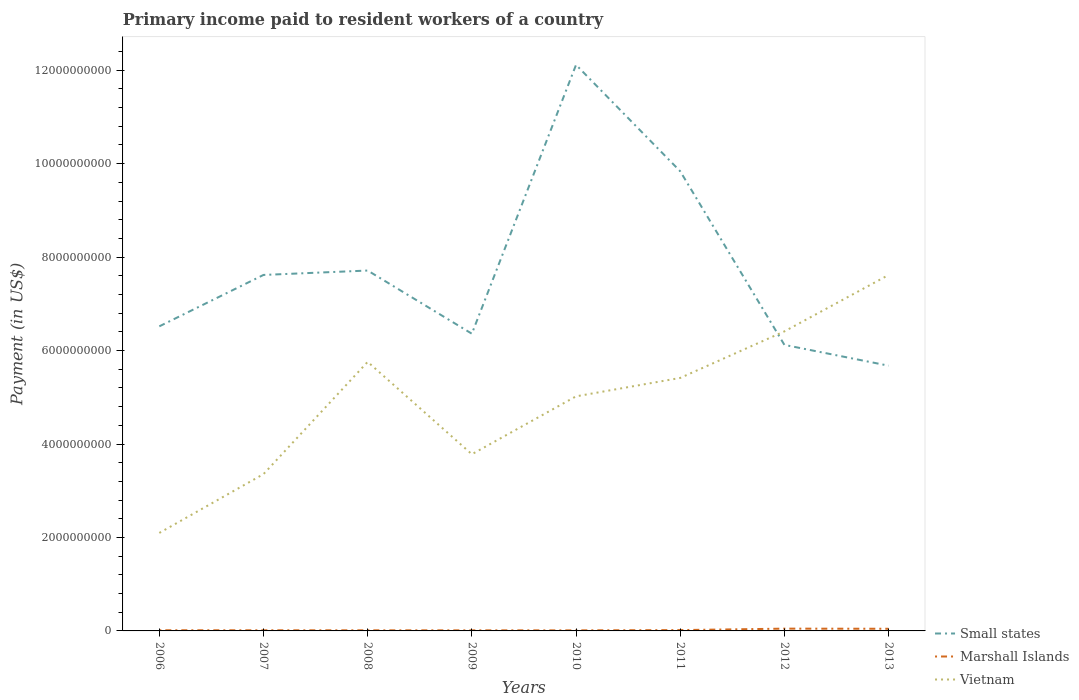How many different coloured lines are there?
Offer a very short reply. 3. Does the line corresponding to Marshall Islands intersect with the line corresponding to Small states?
Keep it short and to the point. No. Across all years, what is the maximum amount paid to workers in Small states?
Your answer should be very brief. 5.68e+09. In which year was the amount paid to workers in Marshall Islands maximum?
Your answer should be compact. 2010. What is the total amount paid to workers in Marshall Islands in the graph?
Keep it short and to the point. -3.13e+07. What is the difference between the highest and the second highest amount paid to workers in Marshall Islands?
Make the answer very short. 3.69e+07. How many lines are there?
Your answer should be very brief. 3. How many years are there in the graph?
Your response must be concise. 8. Are the values on the major ticks of Y-axis written in scientific E-notation?
Your response must be concise. No. How many legend labels are there?
Your response must be concise. 3. What is the title of the graph?
Your answer should be compact. Primary income paid to resident workers of a country. Does "Malaysia" appear as one of the legend labels in the graph?
Your answer should be compact. No. What is the label or title of the X-axis?
Your answer should be compact. Years. What is the label or title of the Y-axis?
Offer a terse response. Payment (in US$). What is the Payment (in US$) of Small states in 2006?
Offer a very short reply. 6.52e+09. What is the Payment (in US$) of Marshall Islands in 2006?
Keep it short and to the point. 1.44e+07. What is the Payment (in US$) of Vietnam in 2006?
Provide a short and direct response. 2.10e+09. What is the Payment (in US$) of Small states in 2007?
Your answer should be very brief. 7.62e+09. What is the Payment (in US$) in Marshall Islands in 2007?
Give a very brief answer. 1.37e+07. What is the Payment (in US$) of Vietnam in 2007?
Keep it short and to the point. 3.36e+09. What is the Payment (in US$) of Small states in 2008?
Provide a short and direct response. 7.71e+09. What is the Payment (in US$) in Marshall Islands in 2008?
Your response must be concise. 1.29e+07. What is the Payment (in US$) of Vietnam in 2008?
Offer a terse response. 5.76e+09. What is the Payment (in US$) in Small states in 2009?
Offer a terse response. 6.36e+09. What is the Payment (in US$) of Marshall Islands in 2009?
Your answer should be compact. 1.23e+07. What is the Payment (in US$) of Vietnam in 2009?
Keep it short and to the point. 3.78e+09. What is the Payment (in US$) in Small states in 2010?
Your answer should be very brief. 1.21e+1. What is the Payment (in US$) of Marshall Islands in 2010?
Ensure brevity in your answer.  1.21e+07. What is the Payment (in US$) in Vietnam in 2010?
Ensure brevity in your answer.  5.02e+09. What is the Payment (in US$) of Small states in 2011?
Offer a very short reply. 9.84e+09. What is the Payment (in US$) in Marshall Islands in 2011?
Offer a very short reply. 1.76e+07. What is the Payment (in US$) of Vietnam in 2011?
Offer a very short reply. 5.41e+09. What is the Payment (in US$) in Small states in 2012?
Your answer should be very brief. 6.12e+09. What is the Payment (in US$) of Marshall Islands in 2012?
Provide a succinct answer. 4.90e+07. What is the Payment (in US$) in Vietnam in 2012?
Ensure brevity in your answer.  6.41e+09. What is the Payment (in US$) in Small states in 2013?
Offer a terse response. 5.68e+09. What is the Payment (in US$) of Marshall Islands in 2013?
Provide a short and direct response. 4.61e+07. What is the Payment (in US$) in Vietnam in 2013?
Ensure brevity in your answer.  7.62e+09. Across all years, what is the maximum Payment (in US$) of Small states?
Give a very brief answer. 1.21e+1. Across all years, what is the maximum Payment (in US$) of Marshall Islands?
Ensure brevity in your answer.  4.90e+07. Across all years, what is the maximum Payment (in US$) of Vietnam?
Offer a very short reply. 7.62e+09. Across all years, what is the minimum Payment (in US$) in Small states?
Ensure brevity in your answer.  5.68e+09. Across all years, what is the minimum Payment (in US$) in Marshall Islands?
Ensure brevity in your answer.  1.21e+07. Across all years, what is the minimum Payment (in US$) of Vietnam?
Provide a short and direct response. 2.10e+09. What is the total Payment (in US$) in Small states in the graph?
Offer a very short reply. 6.20e+1. What is the total Payment (in US$) in Marshall Islands in the graph?
Keep it short and to the point. 1.78e+08. What is the total Payment (in US$) of Vietnam in the graph?
Your answer should be very brief. 3.95e+1. What is the difference between the Payment (in US$) in Small states in 2006 and that in 2007?
Ensure brevity in your answer.  -1.10e+09. What is the difference between the Payment (in US$) of Marshall Islands in 2006 and that in 2007?
Keep it short and to the point. 6.94e+05. What is the difference between the Payment (in US$) of Vietnam in 2006 and that in 2007?
Give a very brief answer. -1.26e+09. What is the difference between the Payment (in US$) in Small states in 2006 and that in 2008?
Your response must be concise. -1.19e+09. What is the difference between the Payment (in US$) in Marshall Islands in 2006 and that in 2008?
Ensure brevity in your answer.  1.47e+06. What is the difference between the Payment (in US$) of Vietnam in 2006 and that in 2008?
Offer a terse response. -3.66e+09. What is the difference between the Payment (in US$) of Small states in 2006 and that in 2009?
Make the answer very short. 1.58e+08. What is the difference between the Payment (in US$) of Marshall Islands in 2006 and that in 2009?
Offer a terse response. 2.08e+06. What is the difference between the Payment (in US$) of Vietnam in 2006 and that in 2009?
Provide a short and direct response. -1.68e+09. What is the difference between the Payment (in US$) in Small states in 2006 and that in 2010?
Your answer should be very brief. -5.60e+09. What is the difference between the Payment (in US$) of Marshall Islands in 2006 and that in 2010?
Provide a succinct answer. 2.29e+06. What is the difference between the Payment (in US$) of Vietnam in 2006 and that in 2010?
Offer a terse response. -2.92e+09. What is the difference between the Payment (in US$) in Small states in 2006 and that in 2011?
Offer a very short reply. -3.32e+09. What is the difference between the Payment (in US$) of Marshall Islands in 2006 and that in 2011?
Your response must be concise. -3.22e+06. What is the difference between the Payment (in US$) of Vietnam in 2006 and that in 2011?
Provide a succinct answer. -3.32e+09. What is the difference between the Payment (in US$) of Small states in 2006 and that in 2012?
Ensure brevity in your answer.  3.97e+08. What is the difference between the Payment (in US$) in Marshall Islands in 2006 and that in 2012?
Keep it short and to the point. -3.46e+07. What is the difference between the Payment (in US$) of Vietnam in 2006 and that in 2012?
Your answer should be very brief. -4.31e+09. What is the difference between the Payment (in US$) of Small states in 2006 and that in 2013?
Provide a succinct answer. 8.42e+08. What is the difference between the Payment (in US$) in Marshall Islands in 2006 and that in 2013?
Your answer should be very brief. -3.17e+07. What is the difference between the Payment (in US$) in Vietnam in 2006 and that in 2013?
Provide a short and direct response. -5.52e+09. What is the difference between the Payment (in US$) of Small states in 2007 and that in 2008?
Make the answer very short. -9.41e+07. What is the difference between the Payment (in US$) in Marshall Islands in 2007 and that in 2008?
Offer a very short reply. 7.72e+05. What is the difference between the Payment (in US$) of Vietnam in 2007 and that in 2008?
Your answer should be very brief. -2.40e+09. What is the difference between the Payment (in US$) in Small states in 2007 and that in 2009?
Give a very brief answer. 1.26e+09. What is the difference between the Payment (in US$) of Marshall Islands in 2007 and that in 2009?
Provide a short and direct response. 1.39e+06. What is the difference between the Payment (in US$) of Vietnam in 2007 and that in 2009?
Give a very brief answer. -4.25e+08. What is the difference between the Payment (in US$) in Small states in 2007 and that in 2010?
Offer a very short reply. -4.50e+09. What is the difference between the Payment (in US$) of Marshall Islands in 2007 and that in 2010?
Your response must be concise. 1.59e+06. What is the difference between the Payment (in US$) of Vietnam in 2007 and that in 2010?
Keep it short and to the point. -1.66e+09. What is the difference between the Payment (in US$) in Small states in 2007 and that in 2011?
Offer a terse response. -2.22e+09. What is the difference between the Payment (in US$) of Marshall Islands in 2007 and that in 2011?
Give a very brief answer. -3.91e+06. What is the difference between the Payment (in US$) of Vietnam in 2007 and that in 2011?
Provide a succinct answer. -2.06e+09. What is the difference between the Payment (in US$) of Small states in 2007 and that in 2012?
Offer a very short reply. 1.50e+09. What is the difference between the Payment (in US$) of Marshall Islands in 2007 and that in 2012?
Offer a terse response. -3.53e+07. What is the difference between the Payment (in US$) of Vietnam in 2007 and that in 2012?
Your answer should be compact. -3.05e+09. What is the difference between the Payment (in US$) in Small states in 2007 and that in 2013?
Make the answer very short. 1.94e+09. What is the difference between the Payment (in US$) of Marshall Islands in 2007 and that in 2013?
Provide a succinct answer. -3.24e+07. What is the difference between the Payment (in US$) in Vietnam in 2007 and that in 2013?
Your answer should be very brief. -4.26e+09. What is the difference between the Payment (in US$) in Small states in 2008 and that in 2009?
Offer a very short reply. 1.35e+09. What is the difference between the Payment (in US$) in Marshall Islands in 2008 and that in 2009?
Provide a short and direct response. 6.16e+05. What is the difference between the Payment (in US$) of Vietnam in 2008 and that in 2009?
Offer a very short reply. 1.98e+09. What is the difference between the Payment (in US$) of Small states in 2008 and that in 2010?
Your answer should be very brief. -4.40e+09. What is the difference between the Payment (in US$) in Marshall Islands in 2008 and that in 2010?
Provide a succinct answer. 8.22e+05. What is the difference between the Payment (in US$) of Vietnam in 2008 and that in 2010?
Give a very brief answer. 7.38e+08. What is the difference between the Payment (in US$) of Small states in 2008 and that in 2011?
Make the answer very short. -2.12e+09. What is the difference between the Payment (in US$) in Marshall Islands in 2008 and that in 2011?
Ensure brevity in your answer.  -4.69e+06. What is the difference between the Payment (in US$) of Vietnam in 2008 and that in 2011?
Ensure brevity in your answer.  3.44e+08. What is the difference between the Payment (in US$) in Small states in 2008 and that in 2012?
Give a very brief answer. 1.59e+09. What is the difference between the Payment (in US$) in Marshall Islands in 2008 and that in 2012?
Offer a very short reply. -3.60e+07. What is the difference between the Payment (in US$) in Vietnam in 2008 and that in 2012?
Your answer should be very brief. -6.52e+08. What is the difference between the Payment (in US$) in Small states in 2008 and that in 2013?
Your answer should be compact. 2.04e+09. What is the difference between the Payment (in US$) of Marshall Islands in 2008 and that in 2013?
Offer a very short reply. -3.32e+07. What is the difference between the Payment (in US$) of Vietnam in 2008 and that in 2013?
Offer a very short reply. -1.86e+09. What is the difference between the Payment (in US$) of Small states in 2009 and that in 2010?
Provide a short and direct response. -5.75e+09. What is the difference between the Payment (in US$) in Marshall Islands in 2009 and that in 2010?
Keep it short and to the point. 2.06e+05. What is the difference between the Payment (in US$) of Vietnam in 2009 and that in 2010?
Your answer should be compact. -1.24e+09. What is the difference between the Payment (in US$) of Small states in 2009 and that in 2011?
Your answer should be very brief. -3.48e+09. What is the difference between the Payment (in US$) of Marshall Islands in 2009 and that in 2011?
Give a very brief answer. -5.30e+06. What is the difference between the Payment (in US$) in Vietnam in 2009 and that in 2011?
Keep it short and to the point. -1.63e+09. What is the difference between the Payment (in US$) of Small states in 2009 and that in 2012?
Your answer should be compact. 2.39e+08. What is the difference between the Payment (in US$) in Marshall Islands in 2009 and that in 2012?
Offer a terse response. -3.66e+07. What is the difference between the Payment (in US$) in Vietnam in 2009 and that in 2012?
Give a very brief answer. -2.63e+09. What is the difference between the Payment (in US$) in Small states in 2009 and that in 2013?
Provide a succinct answer. 6.84e+08. What is the difference between the Payment (in US$) of Marshall Islands in 2009 and that in 2013?
Keep it short and to the point. -3.38e+07. What is the difference between the Payment (in US$) in Vietnam in 2009 and that in 2013?
Ensure brevity in your answer.  -3.84e+09. What is the difference between the Payment (in US$) in Small states in 2010 and that in 2011?
Your answer should be compact. 2.28e+09. What is the difference between the Payment (in US$) in Marshall Islands in 2010 and that in 2011?
Provide a short and direct response. -5.51e+06. What is the difference between the Payment (in US$) of Vietnam in 2010 and that in 2011?
Provide a succinct answer. -3.94e+08. What is the difference between the Payment (in US$) in Small states in 2010 and that in 2012?
Provide a succinct answer. 5.99e+09. What is the difference between the Payment (in US$) in Marshall Islands in 2010 and that in 2012?
Offer a terse response. -3.69e+07. What is the difference between the Payment (in US$) in Vietnam in 2010 and that in 2012?
Your answer should be very brief. -1.39e+09. What is the difference between the Payment (in US$) in Small states in 2010 and that in 2013?
Your answer should be very brief. 6.44e+09. What is the difference between the Payment (in US$) in Marshall Islands in 2010 and that in 2013?
Your answer should be compact. -3.40e+07. What is the difference between the Payment (in US$) in Vietnam in 2010 and that in 2013?
Provide a succinct answer. -2.60e+09. What is the difference between the Payment (in US$) in Small states in 2011 and that in 2012?
Your response must be concise. 3.72e+09. What is the difference between the Payment (in US$) of Marshall Islands in 2011 and that in 2012?
Make the answer very short. -3.13e+07. What is the difference between the Payment (in US$) of Vietnam in 2011 and that in 2012?
Offer a terse response. -9.96e+08. What is the difference between the Payment (in US$) in Small states in 2011 and that in 2013?
Your answer should be very brief. 4.16e+09. What is the difference between the Payment (in US$) in Marshall Islands in 2011 and that in 2013?
Provide a succinct answer. -2.85e+07. What is the difference between the Payment (in US$) of Vietnam in 2011 and that in 2013?
Ensure brevity in your answer.  -2.20e+09. What is the difference between the Payment (in US$) in Small states in 2012 and that in 2013?
Offer a very short reply. 4.45e+08. What is the difference between the Payment (in US$) of Marshall Islands in 2012 and that in 2013?
Ensure brevity in your answer.  2.83e+06. What is the difference between the Payment (in US$) in Vietnam in 2012 and that in 2013?
Your response must be concise. -1.21e+09. What is the difference between the Payment (in US$) of Small states in 2006 and the Payment (in US$) of Marshall Islands in 2007?
Provide a short and direct response. 6.50e+09. What is the difference between the Payment (in US$) of Small states in 2006 and the Payment (in US$) of Vietnam in 2007?
Keep it short and to the point. 3.16e+09. What is the difference between the Payment (in US$) in Marshall Islands in 2006 and the Payment (in US$) in Vietnam in 2007?
Offer a terse response. -3.34e+09. What is the difference between the Payment (in US$) in Small states in 2006 and the Payment (in US$) in Marshall Islands in 2008?
Keep it short and to the point. 6.51e+09. What is the difference between the Payment (in US$) in Small states in 2006 and the Payment (in US$) in Vietnam in 2008?
Offer a terse response. 7.60e+08. What is the difference between the Payment (in US$) of Marshall Islands in 2006 and the Payment (in US$) of Vietnam in 2008?
Provide a short and direct response. -5.74e+09. What is the difference between the Payment (in US$) in Small states in 2006 and the Payment (in US$) in Marshall Islands in 2009?
Give a very brief answer. 6.51e+09. What is the difference between the Payment (in US$) of Small states in 2006 and the Payment (in US$) of Vietnam in 2009?
Offer a terse response. 2.74e+09. What is the difference between the Payment (in US$) in Marshall Islands in 2006 and the Payment (in US$) in Vietnam in 2009?
Provide a succinct answer. -3.77e+09. What is the difference between the Payment (in US$) of Small states in 2006 and the Payment (in US$) of Marshall Islands in 2010?
Make the answer very short. 6.51e+09. What is the difference between the Payment (in US$) in Small states in 2006 and the Payment (in US$) in Vietnam in 2010?
Provide a short and direct response. 1.50e+09. What is the difference between the Payment (in US$) of Marshall Islands in 2006 and the Payment (in US$) of Vietnam in 2010?
Offer a terse response. -5.01e+09. What is the difference between the Payment (in US$) in Small states in 2006 and the Payment (in US$) in Marshall Islands in 2011?
Ensure brevity in your answer.  6.50e+09. What is the difference between the Payment (in US$) in Small states in 2006 and the Payment (in US$) in Vietnam in 2011?
Keep it short and to the point. 1.10e+09. What is the difference between the Payment (in US$) of Marshall Islands in 2006 and the Payment (in US$) of Vietnam in 2011?
Offer a terse response. -5.40e+09. What is the difference between the Payment (in US$) of Small states in 2006 and the Payment (in US$) of Marshall Islands in 2012?
Provide a short and direct response. 6.47e+09. What is the difference between the Payment (in US$) of Small states in 2006 and the Payment (in US$) of Vietnam in 2012?
Make the answer very short. 1.08e+08. What is the difference between the Payment (in US$) of Marshall Islands in 2006 and the Payment (in US$) of Vietnam in 2012?
Your answer should be compact. -6.40e+09. What is the difference between the Payment (in US$) of Small states in 2006 and the Payment (in US$) of Marshall Islands in 2013?
Keep it short and to the point. 6.47e+09. What is the difference between the Payment (in US$) in Small states in 2006 and the Payment (in US$) in Vietnam in 2013?
Offer a very short reply. -1.10e+09. What is the difference between the Payment (in US$) in Marshall Islands in 2006 and the Payment (in US$) in Vietnam in 2013?
Keep it short and to the point. -7.60e+09. What is the difference between the Payment (in US$) of Small states in 2007 and the Payment (in US$) of Marshall Islands in 2008?
Give a very brief answer. 7.61e+09. What is the difference between the Payment (in US$) in Small states in 2007 and the Payment (in US$) in Vietnam in 2008?
Provide a succinct answer. 1.86e+09. What is the difference between the Payment (in US$) of Marshall Islands in 2007 and the Payment (in US$) of Vietnam in 2008?
Provide a succinct answer. -5.74e+09. What is the difference between the Payment (in US$) of Small states in 2007 and the Payment (in US$) of Marshall Islands in 2009?
Provide a short and direct response. 7.61e+09. What is the difference between the Payment (in US$) of Small states in 2007 and the Payment (in US$) of Vietnam in 2009?
Make the answer very short. 3.84e+09. What is the difference between the Payment (in US$) of Marshall Islands in 2007 and the Payment (in US$) of Vietnam in 2009?
Provide a short and direct response. -3.77e+09. What is the difference between the Payment (in US$) of Small states in 2007 and the Payment (in US$) of Marshall Islands in 2010?
Your answer should be compact. 7.61e+09. What is the difference between the Payment (in US$) of Small states in 2007 and the Payment (in US$) of Vietnam in 2010?
Keep it short and to the point. 2.60e+09. What is the difference between the Payment (in US$) of Marshall Islands in 2007 and the Payment (in US$) of Vietnam in 2010?
Offer a terse response. -5.01e+09. What is the difference between the Payment (in US$) in Small states in 2007 and the Payment (in US$) in Marshall Islands in 2011?
Make the answer very short. 7.60e+09. What is the difference between the Payment (in US$) of Small states in 2007 and the Payment (in US$) of Vietnam in 2011?
Provide a succinct answer. 2.20e+09. What is the difference between the Payment (in US$) of Marshall Islands in 2007 and the Payment (in US$) of Vietnam in 2011?
Offer a terse response. -5.40e+09. What is the difference between the Payment (in US$) in Small states in 2007 and the Payment (in US$) in Marshall Islands in 2012?
Offer a very short reply. 7.57e+09. What is the difference between the Payment (in US$) in Small states in 2007 and the Payment (in US$) in Vietnam in 2012?
Offer a very short reply. 1.21e+09. What is the difference between the Payment (in US$) in Marshall Islands in 2007 and the Payment (in US$) in Vietnam in 2012?
Your answer should be compact. -6.40e+09. What is the difference between the Payment (in US$) in Small states in 2007 and the Payment (in US$) in Marshall Islands in 2013?
Your answer should be very brief. 7.57e+09. What is the difference between the Payment (in US$) of Small states in 2007 and the Payment (in US$) of Vietnam in 2013?
Ensure brevity in your answer.  1.15e+06. What is the difference between the Payment (in US$) in Marshall Islands in 2007 and the Payment (in US$) in Vietnam in 2013?
Provide a succinct answer. -7.60e+09. What is the difference between the Payment (in US$) in Small states in 2008 and the Payment (in US$) in Marshall Islands in 2009?
Offer a very short reply. 7.70e+09. What is the difference between the Payment (in US$) in Small states in 2008 and the Payment (in US$) in Vietnam in 2009?
Give a very brief answer. 3.93e+09. What is the difference between the Payment (in US$) in Marshall Islands in 2008 and the Payment (in US$) in Vietnam in 2009?
Your answer should be compact. -3.77e+09. What is the difference between the Payment (in US$) of Small states in 2008 and the Payment (in US$) of Marshall Islands in 2010?
Provide a succinct answer. 7.70e+09. What is the difference between the Payment (in US$) in Small states in 2008 and the Payment (in US$) in Vietnam in 2010?
Keep it short and to the point. 2.69e+09. What is the difference between the Payment (in US$) of Marshall Islands in 2008 and the Payment (in US$) of Vietnam in 2010?
Offer a very short reply. -5.01e+09. What is the difference between the Payment (in US$) of Small states in 2008 and the Payment (in US$) of Marshall Islands in 2011?
Offer a terse response. 7.69e+09. What is the difference between the Payment (in US$) in Small states in 2008 and the Payment (in US$) in Vietnam in 2011?
Provide a short and direct response. 2.30e+09. What is the difference between the Payment (in US$) of Marshall Islands in 2008 and the Payment (in US$) of Vietnam in 2011?
Ensure brevity in your answer.  -5.40e+09. What is the difference between the Payment (in US$) in Small states in 2008 and the Payment (in US$) in Marshall Islands in 2012?
Make the answer very short. 7.66e+09. What is the difference between the Payment (in US$) in Small states in 2008 and the Payment (in US$) in Vietnam in 2012?
Provide a short and direct response. 1.30e+09. What is the difference between the Payment (in US$) of Marshall Islands in 2008 and the Payment (in US$) of Vietnam in 2012?
Offer a very short reply. -6.40e+09. What is the difference between the Payment (in US$) of Small states in 2008 and the Payment (in US$) of Marshall Islands in 2013?
Ensure brevity in your answer.  7.67e+09. What is the difference between the Payment (in US$) of Small states in 2008 and the Payment (in US$) of Vietnam in 2013?
Keep it short and to the point. 9.53e+07. What is the difference between the Payment (in US$) in Marshall Islands in 2008 and the Payment (in US$) in Vietnam in 2013?
Give a very brief answer. -7.60e+09. What is the difference between the Payment (in US$) of Small states in 2009 and the Payment (in US$) of Marshall Islands in 2010?
Provide a short and direct response. 6.35e+09. What is the difference between the Payment (in US$) in Small states in 2009 and the Payment (in US$) in Vietnam in 2010?
Ensure brevity in your answer.  1.34e+09. What is the difference between the Payment (in US$) of Marshall Islands in 2009 and the Payment (in US$) of Vietnam in 2010?
Give a very brief answer. -5.01e+09. What is the difference between the Payment (in US$) of Small states in 2009 and the Payment (in US$) of Marshall Islands in 2011?
Your response must be concise. 6.34e+09. What is the difference between the Payment (in US$) of Small states in 2009 and the Payment (in US$) of Vietnam in 2011?
Offer a very short reply. 9.46e+08. What is the difference between the Payment (in US$) in Marshall Islands in 2009 and the Payment (in US$) in Vietnam in 2011?
Your answer should be compact. -5.40e+09. What is the difference between the Payment (in US$) in Small states in 2009 and the Payment (in US$) in Marshall Islands in 2012?
Provide a short and direct response. 6.31e+09. What is the difference between the Payment (in US$) of Small states in 2009 and the Payment (in US$) of Vietnam in 2012?
Your answer should be compact. -4.98e+07. What is the difference between the Payment (in US$) of Marshall Islands in 2009 and the Payment (in US$) of Vietnam in 2012?
Provide a succinct answer. -6.40e+09. What is the difference between the Payment (in US$) of Small states in 2009 and the Payment (in US$) of Marshall Islands in 2013?
Your response must be concise. 6.31e+09. What is the difference between the Payment (in US$) in Small states in 2009 and the Payment (in US$) in Vietnam in 2013?
Keep it short and to the point. -1.26e+09. What is the difference between the Payment (in US$) in Marshall Islands in 2009 and the Payment (in US$) in Vietnam in 2013?
Your answer should be very brief. -7.60e+09. What is the difference between the Payment (in US$) of Small states in 2010 and the Payment (in US$) of Marshall Islands in 2011?
Keep it short and to the point. 1.21e+1. What is the difference between the Payment (in US$) of Small states in 2010 and the Payment (in US$) of Vietnam in 2011?
Your response must be concise. 6.70e+09. What is the difference between the Payment (in US$) in Marshall Islands in 2010 and the Payment (in US$) in Vietnam in 2011?
Keep it short and to the point. -5.40e+09. What is the difference between the Payment (in US$) of Small states in 2010 and the Payment (in US$) of Marshall Islands in 2012?
Ensure brevity in your answer.  1.21e+1. What is the difference between the Payment (in US$) of Small states in 2010 and the Payment (in US$) of Vietnam in 2012?
Provide a short and direct response. 5.70e+09. What is the difference between the Payment (in US$) in Marshall Islands in 2010 and the Payment (in US$) in Vietnam in 2012?
Your answer should be compact. -6.40e+09. What is the difference between the Payment (in US$) in Small states in 2010 and the Payment (in US$) in Marshall Islands in 2013?
Ensure brevity in your answer.  1.21e+1. What is the difference between the Payment (in US$) in Small states in 2010 and the Payment (in US$) in Vietnam in 2013?
Ensure brevity in your answer.  4.50e+09. What is the difference between the Payment (in US$) of Marshall Islands in 2010 and the Payment (in US$) of Vietnam in 2013?
Provide a succinct answer. -7.60e+09. What is the difference between the Payment (in US$) of Small states in 2011 and the Payment (in US$) of Marshall Islands in 2012?
Offer a terse response. 9.79e+09. What is the difference between the Payment (in US$) of Small states in 2011 and the Payment (in US$) of Vietnam in 2012?
Your answer should be compact. 3.43e+09. What is the difference between the Payment (in US$) of Marshall Islands in 2011 and the Payment (in US$) of Vietnam in 2012?
Provide a succinct answer. -6.39e+09. What is the difference between the Payment (in US$) of Small states in 2011 and the Payment (in US$) of Marshall Islands in 2013?
Keep it short and to the point. 9.79e+09. What is the difference between the Payment (in US$) in Small states in 2011 and the Payment (in US$) in Vietnam in 2013?
Ensure brevity in your answer.  2.22e+09. What is the difference between the Payment (in US$) in Marshall Islands in 2011 and the Payment (in US$) in Vietnam in 2013?
Make the answer very short. -7.60e+09. What is the difference between the Payment (in US$) of Small states in 2012 and the Payment (in US$) of Marshall Islands in 2013?
Make the answer very short. 6.08e+09. What is the difference between the Payment (in US$) of Small states in 2012 and the Payment (in US$) of Vietnam in 2013?
Provide a short and direct response. -1.50e+09. What is the difference between the Payment (in US$) in Marshall Islands in 2012 and the Payment (in US$) in Vietnam in 2013?
Provide a succinct answer. -7.57e+09. What is the average Payment (in US$) of Small states per year?
Your response must be concise. 7.74e+09. What is the average Payment (in US$) in Marshall Islands per year?
Keep it short and to the point. 2.23e+07. What is the average Payment (in US$) in Vietnam per year?
Provide a succinct answer. 4.93e+09. In the year 2006, what is the difference between the Payment (in US$) in Small states and Payment (in US$) in Marshall Islands?
Provide a short and direct response. 6.50e+09. In the year 2006, what is the difference between the Payment (in US$) of Small states and Payment (in US$) of Vietnam?
Ensure brevity in your answer.  4.42e+09. In the year 2006, what is the difference between the Payment (in US$) in Marshall Islands and Payment (in US$) in Vietnam?
Your answer should be very brief. -2.08e+09. In the year 2007, what is the difference between the Payment (in US$) of Small states and Payment (in US$) of Marshall Islands?
Give a very brief answer. 7.60e+09. In the year 2007, what is the difference between the Payment (in US$) in Small states and Payment (in US$) in Vietnam?
Your response must be concise. 4.26e+09. In the year 2007, what is the difference between the Payment (in US$) of Marshall Islands and Payment (in US$) of Vietnam?
Keep it short and to the point. -3.34e+09. In the year 2008, what is the difference between the Payment (in US$) of Small states and Payment (in US$) of Marshall Islands?
Offer a terse response. 7.70e+09. In the year 2008, what is the difference between the Payment (in US$) of Small states and Payment (in US$) of Vietnam?
Keep it short and to the point. 1.95e+09. In the year 2008, what is the difference between the Payment (in US$) of Marshall Islands and Payment (in US$) of Vietnam?
Your answer should be compact. -5.75e+09. In the year 2009, what is the difference between the Payment (in US$) of Small states and Payment (in US$) of Marshall Islands?
Offer a very short reply. 6.35e+09. In the year 2009, what is the difference between the Payment (in US$) in Small states and Payment (in US$) in Vietnam?
Make the answer very short. 2.58e+09. In the year 2009, what is the difference between the Payment (in US$) of Marshall Islands and Payment (in US$) of Vietnam?
Offer a very short reply. -3.77e+09. In the year 2010, what is the difference between the Payment (in US$) in Small states and Payment (in US$) in Marshall Islands?
Your response must be concise. 1.21e+1. In the year 2010, what is the difference between the Payment (in US$) in Small states and Payment (in US$) in Vietnam?
Provide a short and direct response. 7.09e+09. In the year 2010, what is the difference between the Payment (in US$) in Marshall Islands and Payment (in US$) in Vietnam?
Ensure brevity in your answer.  -5.01e+09. In the year 2011, what is the difference between the Payment (in US$) in Small states and Payment (in US$) in Marshall Islands?
Your answer should be very brief. 9.82e+09. In the year 2011, what is the difference between the Payment (in US$) in Small states and Payment (in US$) in Vietnam?
Keep it short and to the point. 4.42e+09. In the year 2011, what is the difference between the Payment (in US$) of Marshall Islands and Payment (in US$) of Vietnam?
Offer a terse response. -5.40e+09. In the year 2012, what is the difference between the Payment (in US$) of Small states and Payment (in US$) of Marshall Islands?
Offer a terse response. 6.07e+09. In the year 2012, what is the difference between the Payment (in US$) of Small states and Payment (in US$) of Vietnam?
Offer a very short reply. -2.89e+08. In the year 2012, what is the difference between the Payment (in US$) in Marshall Islands and Payment (in US$) in Vietnam?
Your answer should be very brief. -6.36e+09. In the year 2013, what is the difference between the Payment (in US$) of Small states and Payment (in US$) of Marshall Islands?
Offer a terse response. 5.63e+09. In the year 2013, what is the difference between the Payment (in US$) in Small states and Payment (in US$) in Vietnam?
Your answer should be compact. -1.94e+09. In the year 2013, what is the difference between the Payment (in US$) of Marshall Islands and Payment (in US$) of Vietnam?
Your answer should be very brief. -7.57e+09. What is the ratio of the Payment (in US$) of Small states in 2006 to that in 2007?
Ensure brevity in your answer.  0.86. What is the ratio of the Payment (in US$) of Marshall Islands in 2006 to that in 2007?
Give a very brief answer. 1.05. What is the ratio of the Payment (in US$) in Vietnam in 2006 to that in 2007?
Ensure brevity in your answer.  0.62. What is the ratio of the Payment (in US$) of Small states in 2006 to that in 2008?
Offer a very short reply. 0.85. What is the ratio of the Payment (in US$) in Marshall Islands in 2006 to that in 2008?
Provide a succinct answer. 1.11. What is the ratio of the Payment (in US$) of Vietnam in 2006 to that in 2008?
Your response must be concise. 0.36. What is the ratio of the Payment (in US$) of Small states in 2006 to that in 2009?
Ensure brevity in your answer.  1.02. What is the ratio of the Payment (in US$) in Marshall Islands in 2006 to that in 2009?
Your response must be concise. 1.17. What is the ratio of the Payment (in US$) in Vietnam in 2006 to that in 2009?
Give a very brief answer. 0.55. What is the ratio of the Payment (in US$) in Small states in 2006 to that in 2010?
Give a very brief answer. 0.54. What is the ratio of the Payment (in US$) in Marshall Islands in 2006 to that in 2010?
Provide a succinct answer. 1.19. What is the ratio of the Payment (in US$) in Vietnam in 2006 to that in 2010?
Ensure brevity in your answer.  0.42. What is the ratio of the Payment (in US$) in Small states in 2006 to that in 2011?
Your answer should be very brief. 0.66. What is the ratio of the Payment (in US$) of Marshall Islands in 2006 to that in 2011?
Make the answer very short. 0.82. What is the ratio of the Payment (in US$) in Vietnam in 2006 to that in 2011?
Ensure brevity in your answer.  0.39. What is the ratio of the Payment (in US$) in Small states in 2006 to that in 2012?
Your answer should be very brief. 1.06. What is the ratio of the Payment (in US$) in Marshall Islands in 2006 to that in 2012?
Offer a very short reply. 0.29. What is the ratio of the Payment (in US$) in Vietnam in 2006 to that in 2012?
Ensure brevity in your answer.  0.33. What is the ratio of the Payment (in US$) of Small states in 2006 to that in 2013?
Offer a terse response. 1.15. What is the ratio of the Payment (in US$) of Marshall Islands in 2006 to that in 2013?
Provide a succinct answer. 0.31. What is the ratio of the Payment (in US$) of Vietnam in 2006 to that in 2013?
Offer a terse response. 0.28. What is the ratio of the Payment (in US$) of Small states in 2007 to that in 2008?
Your answer should be compact. 0.99. What is the ratio of the Payment (in US$) of Marshall Islands in 2007 to that in 2008?
Your answer should be very brief. 1.06. What is the ratio of the Payment (in US$) in Vietnam in 2007 to that in 2008?
Your answer should be very brief. 0.58. What is the ratio of the Payment (in US$) in Small states in 2007 to that in 2009?
Provide a short and direct response. 1.2. What is the ratio of the Payment (in US$) in Marshall Islands in 2007 to that in 2009?
Provide a short and direct response. 1.11. What is the ratio of the Payment (in US$) in Vietnam in 2007 to that in 2009?
Offer a terse response. 0.89. What is the ratio of the Payment (in US$) in Small states in 2007 to that in 2010?
Provide a succinct answer. 0.63. What is the ratio of the Payment (in US$) in Marshall Islands in 2007 to that in 2010?
Your answer should be compact. 1.13. What is the ratio of the Payment (in US$) of Vietnam in 2007 to that in 2010?
Your response must be concise. 0.67. What is the ratio of the Payment (in US$) in Small states in 2007 to that in 2011?
Make the answer very short. 0.77. What is the ratio of the Payment (in US$) in Marshall Islands in 2007 to that in 2011?
Offer a terse response. 0.78. What is the ratio of the Payment (in US$) in Vietnam in 2007 to that in 2011?
Provide a short and direct response. 0.62. What is the ratio of the Payment (in US$) of Small states in 2007 to that in 2012?
Keep it short and to the point. 1.24. What is the ratio of the Payment (in US$) in Marshall Islands in 2007 to that in 2012?
Ensure brevity in your answer.  0.28. What is the ratio of the Payment (in US$) in Vietnam in 2007 to that in 2012?
Your response must be concise. 0.52. What is the ratio of the Payment (in US$) of Small states in 2007 to that in 2013?
Your response must be concise. 1.34. What is the ratio of the Payment (in US$) of Marshall Islands in 2007 to that in 2013?
Your answer should be compact. 0.3. What is the ratio of the Payment (in US$) in Vietnam in 2007 to that in 2013?
Your answer should be very brief. 0.44. What is the ratio of the Payment (in US$) of Small states in 2008 to that in 2009?
Your answer should be compact. 1.21. What is the ratio of the Payment (in US$) of Marshall Islands in 2008 to that in 2009?
Give a very brief answer. 1.05. What is the ratio of the Payment (in US$) of Vietnam in 2008 to that in 2009?
Offer a terse response. 1.52. What is the ratio of the Payment (in US$) of Small states in 2008 to that in 2010?
Provide a short and direct response. 0.64. What is the ratio of the Payment (in US$) of Marshall Islands in 2008 to that in 2010?
Ensure brevity in your answer.  1.07. What is the ratio of the Payment (in US$) in Vietnam in 2008 to that in 2010?
Your response must be concise. 1.15. What is the ratio of the Payment (in US$) of Small states in 2008 to that in 2011?
Your response must be concise. 0.78. What is the ratio of the Payment (in US$) in Marshall Islands in 2008 to that in 2011?
Make the answer very short. 0.73. What is the ratio of the Payment (in US$) in Vietnam in 2008 to that in 2011?
Ensure brevity in your answer.  1.06. What is the ratio of the Payment (in US$) of Small states in 2008 to that in 2012?
Give a very brief answer. 1.26. What is the ratio of the Payment (in US$) in Marshall Islands in 2008 to that in 2012?
Your answer should be very brief. 0.26. What is the ratio of the Payment (in US$) of Vietnam in 2008 to that in 2012?
Your answer should be compact. 0.9. What is the ratio of the Payment (in US$) of Small states in 2008 to that in 2013?
Ensure brevity in your answer.  1.36. What is the ratio of the Payment (in US$) in Marshall Islands in 2008 to that in 2013?
Your answer should be compact. 0.28. What is the ratio of the Payment (in US$) in Vietnam in 2008 to that in 2013?
Your answer should be compact. 0.76. What is the ratio of the Payment (in US$) of Small states in 2009 to that in 2010?
Your answer should be compact. 0.53. What is the ratio of the Payment (in US$) in Marshall Islands in 2009 to that in 2010?
Provide a succinct answer. 1.02. What is the ratio of the Payment (in US$) in Vietnam in 2009 to that in 2010?
Offer a very short reply. 0.75. What is the ratio of the Payment (in US$) in Small states in 2009 to that in 2011?
Offer a very short reply. 0.65. What is the ratio of the Payment (in US$) in Marshall Islands in 2009 to that in 2011?
Ensure brevity in your answer.  0.7. What is the ratio of the Payment (in US$) in Vietnam in 2009 to that in 2011?
Make the answer very short. 0.7. What is the ratio of the Payment (in US$) in Small states in 2009 to that in 2012?
Ensure brevity in your answer.  1.04. What is the ratio of the Payment (in US$) of Marshall Islands in 2009 to that in 2012?
Keep it short and to the point. 0.25. What is the ratio of the Payment (in US$) of Vietnam in 2009 to that in 2012?
Offer a very short reply. 0.59. What is the ratio of the Payment (in US$) in Small states in 2009 to that in 2013?
Offer a very short reply. 1.12. What is the ratio of the Payment (in US$) in Marshall Islands in 2009 to that in 2013?
Ensure brevity in your answer.  0.27. What is the ratio of the Payment (in US$) in Vietnam in 2009 to that in 2013?
Your response must be concise. 0.5. What is the ratio of the Payment (in US$) in Small states in 2010 to that in 2011?
Offer a very short reply. 1.23. What is the ratio of the Payment (in US$) of Marshall Islands in 2010 to that in 2011?
Make the answer very short. 0.69. What is the ratio of the Payment (in US$) of Vietnam in 2010 to that in 2011?
Offer a terse response. 0.93. What is the ratio of the Payment (in US$) of Small states in 2010 to that in 2012?
Offer a terse response. 1.98. What is the ratio of the Payment (in US$) in Marshall Islands in 2010 to that in 2012?
Offer a very short reply. 0.25. What is the ratio of the Payment (in US$) in Vietnam in 2010 to that in 2012?
Make the answer very short. 0.78. What is the ratio of the Payment (in US$) of Small states in 2010 to that in 2013?
Ensure brevity in your answer.  2.13. What is the ratio of the Payment (in US$) of Marshall Islands in 2010 to that in 2013?
Offer a very short reply. 0.26. What is the ratio of the Payment (in US$) of Vietnam in 2010 to that in 2013?
Your answer should be compact. 0.66. What is the ratio of the Payment (in US$) in Small states in 2011 to that in 2012?
Your answer should be very brief. 1.61. What is the ratio of the Payment (in US$) in Marshall Islands in 2011 to that in 2012?
Provide a succinct answer. 0.36. What is the ratio of the Payment (in US$) of Vietnam in 2011 to that in 2012?
Your answer should be very brief. 0.84. What is the ratio of the Payment (in US$) in Small states in 2011 to that in 2013?
Ensure brevity in your answer.  1.73. What is the ratio of the Payment (in US$) in Marshall Islands in 2011 to that in 2013?
Give a very brief answer. 0.38. What is the ratio of the Payment (in US$) in Vietnam in 2011 to that in 2013?
Offer a terse response. 0.71. What is the ratio of the Payment (in US$) in Small states in 2012 to that in 2013?
Keep it short and to the point. 1.08. What is the ratio of the Payment (in US$) of Marshall Islands in 2012 to that in 2013?
Offer a terse response. 1.06. What is the ratio of the Payment (in US$) in Vietnam in 2012 to that in 2013?
Your answer should be compact. 0.84. What is the difference between the highest and the second highest Payment (in US$) of Small states?
Keep it short and to the point. 2.28e+09. What is the difference between the highest and the second highest Payment (in US$) in Marshall Islands?
Give a very brief answer. 2.83e+06. What is the difference between the highest and the second highest Payment (in US$) in Vietnam?
Ensure brevity in your answer.  1.21e+09. What is the difference between the highest and the lowest Payment (in US$) in Small states?
Give a very brief answer. 6.44e+09. What is the difference between the highest and the lowest Payment (in US$) in Marshall Islands?
Keep it short and to the point. 3.69e+07. What is the difference between the highest and the lowest Payment (in US$) in Vietnam?
Provide a short and direct response. 5.52e+09. 